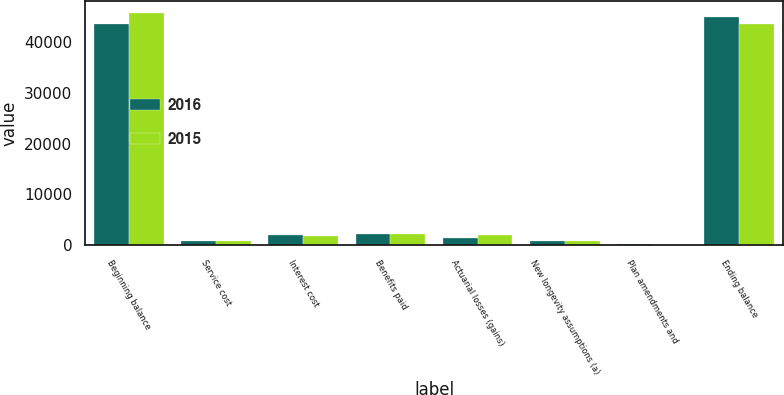Convert chart to OTSL. <chart><loc_0><loc_0><loc_500><loc_500><stacked_bar_chart><ecel><fcel>Beginning balance<fcel>Service cost<fcel>Interest cost<fcel>Benefits paid<fcel>Actuarial losses (gains)<fcel>New longevity assumptions (a)<fcel>Plan amendments and<fcel>Ending balance<nl><fcel>2016<fcel>43702<fcel>827<fcel>1861<fcel>2172<fcel>1402<fcel>687<fcel>110<fcel>45064<nl><fcel>2015<fcel>45882<fcel>836<fcel>1791<fcel>2055<fcel>1988<fcel>834<fcel>31<fcel>43702<nl></chart> 